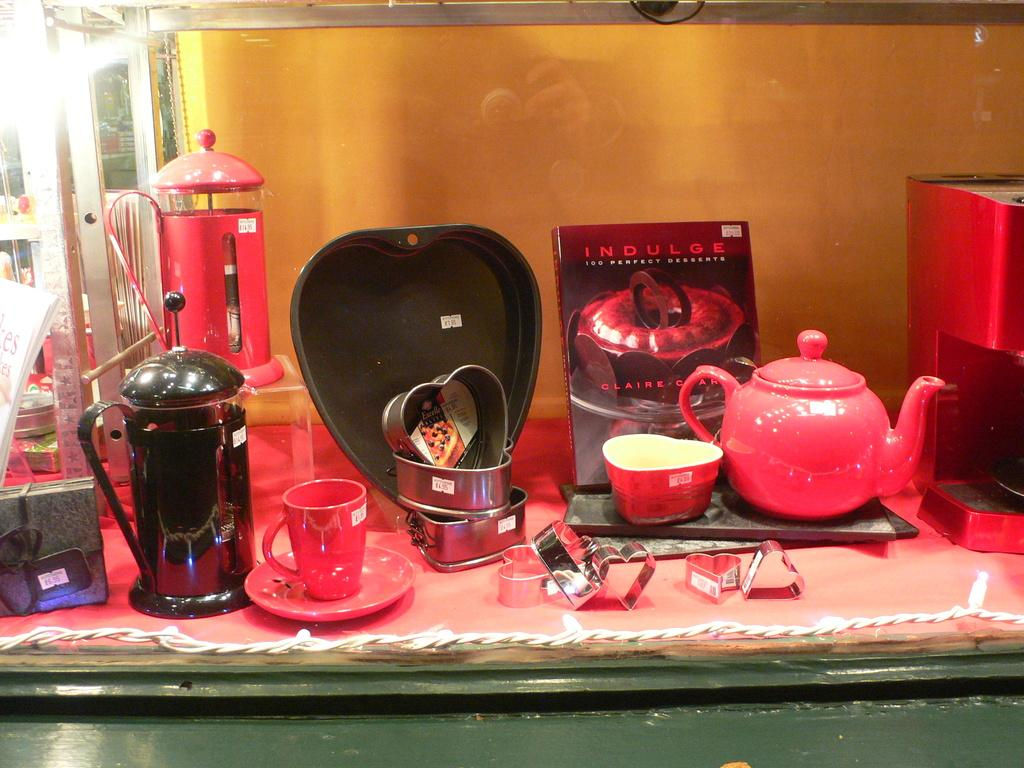<image>
Render a clear and concise summary of the photo. A tea set sits on display accompanied by a book titled "Indulge" 